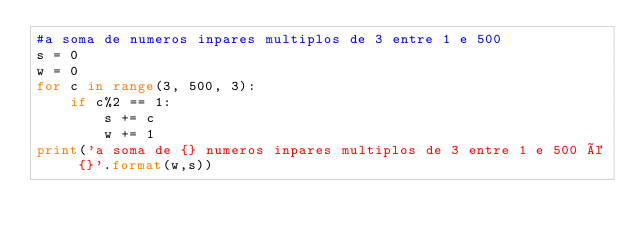Convert code to text. <code><loc_0><loc_0><loc_500><loc_500><_Python_>#a soma de numeros inpares multiplos de 3 entre 1 e 500
s = 0
w = 0
for c in range(3, 500, 3):
    if c%2 == 1:
        s += c
        w += 1
print('a soma de {} numeros inpares multiplos de 3 entre 1 e 500 é {}'.format(w,s))</code> 